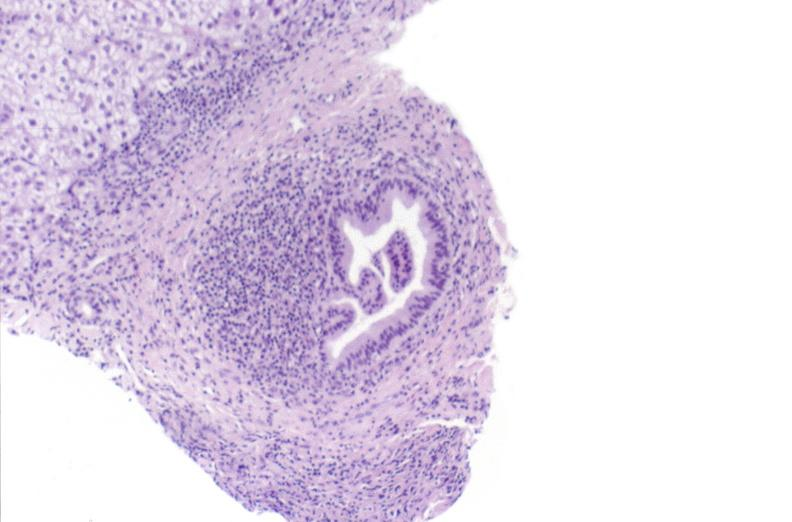s hepatobiliary present?
Answer the question using a single word or phrase. Yes 